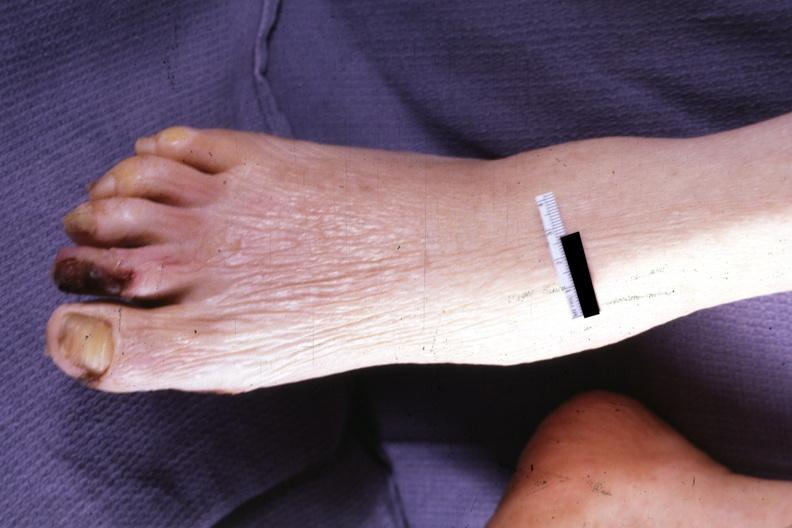what is present?
Answer the question using a single word or phrase. Foot 